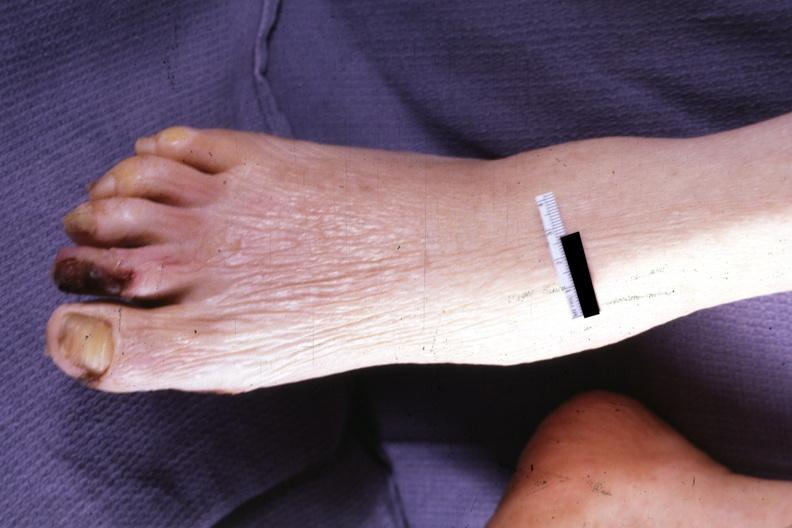what is present?
Answer the question using a single word or phrase. Foot 